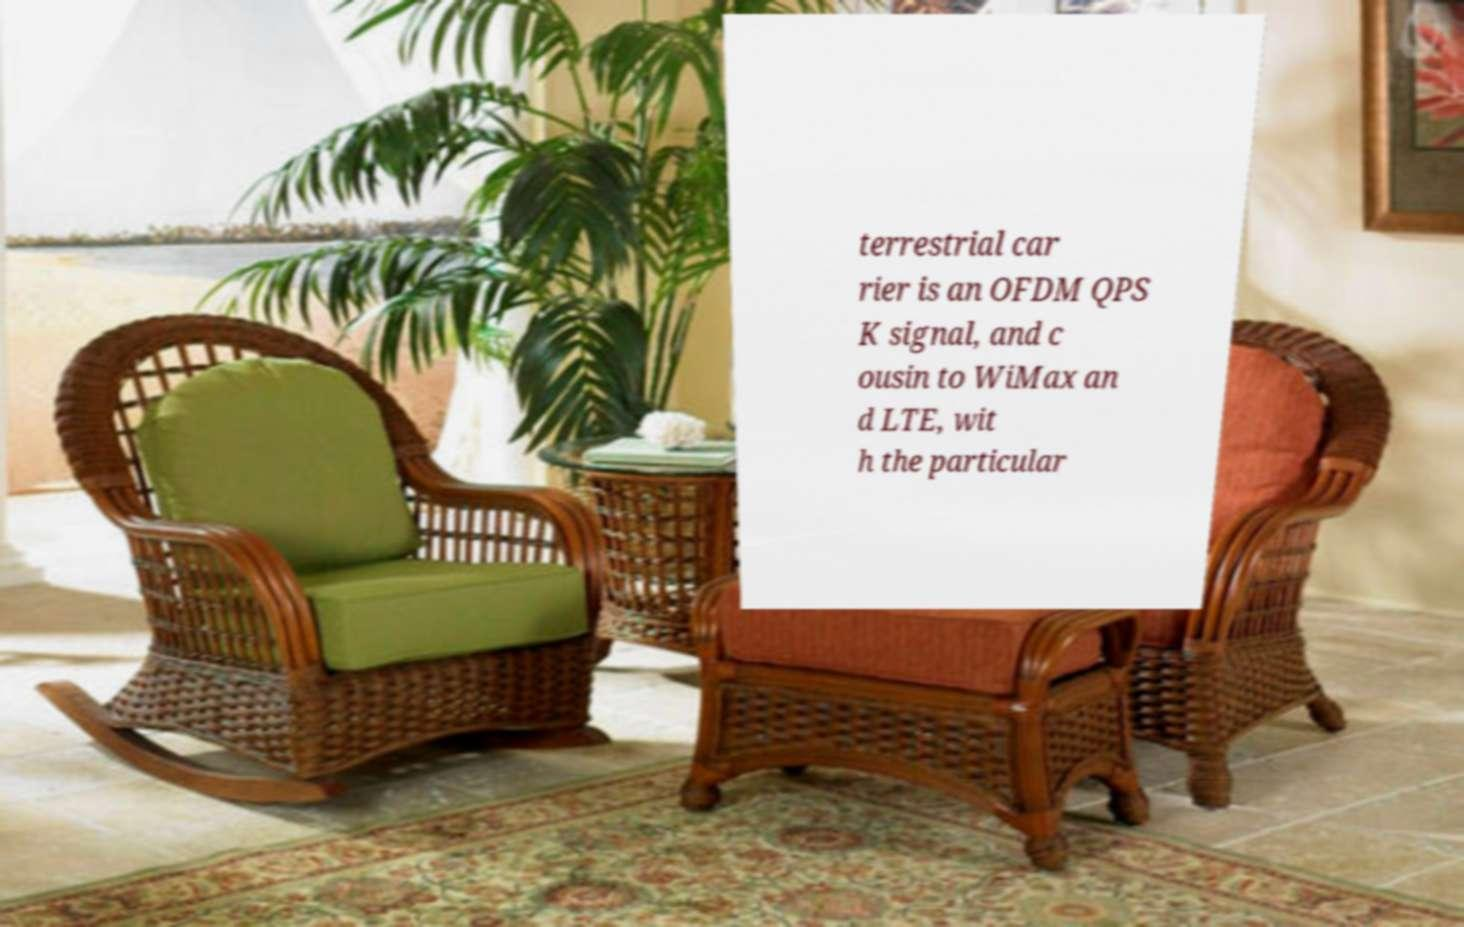Could you assist in decoding the text presented in this image and type it out clearly? terrestrial car rier is an OFDM QPS K signal, and c ousin to WiMax an d LTE, wit h the particular 